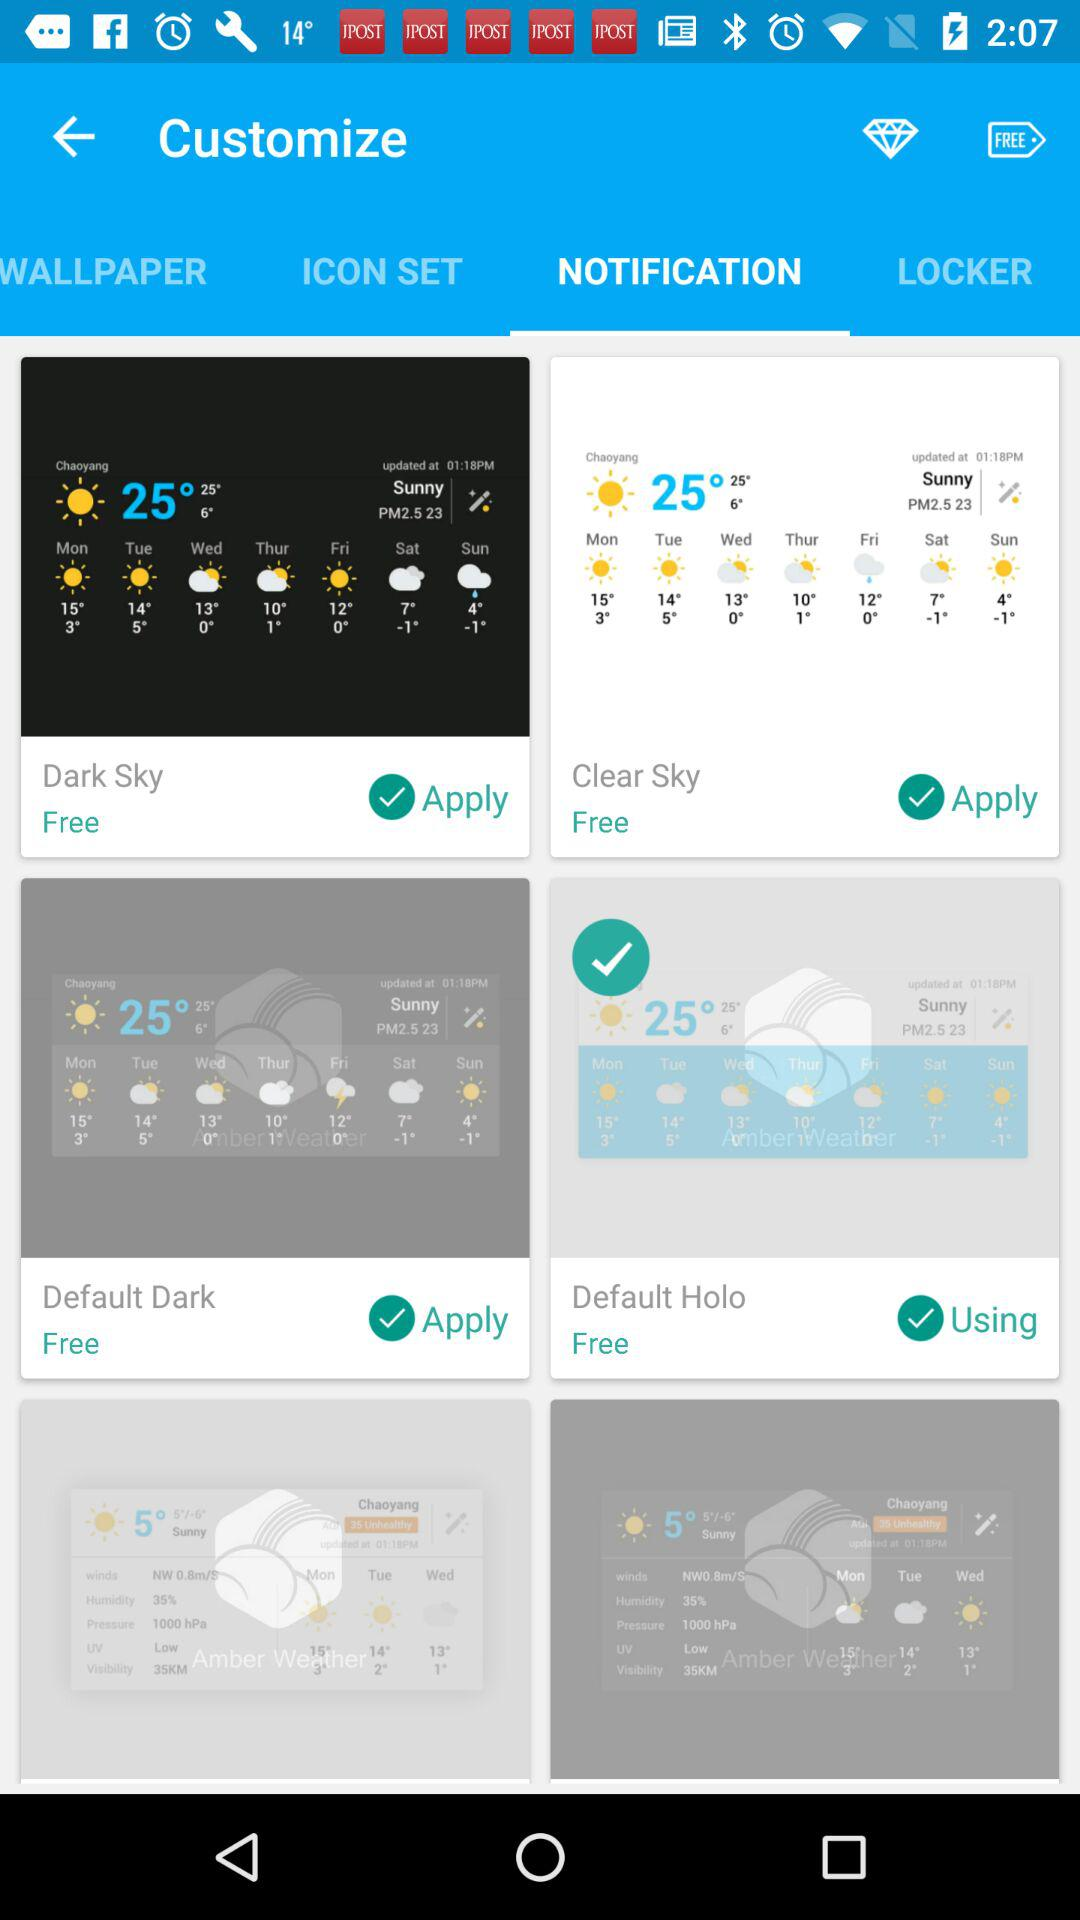Is the "Dark Sky" widget free or paid? The "Dark Sky" widget is free. 